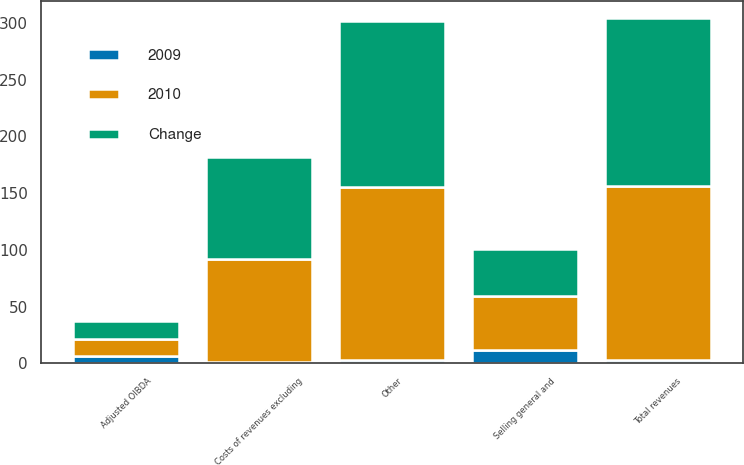Convert chart to OTSL. <chart><loc_0><loc_0><loc_500><loc_500><stacked_bar_chart><ecel><fcel>Other<fcel>Total revenues<fcel>Costs of revenues excluding<fcel>Selling general and<fcel>Adjusted OIBDA<nl><fcel>2010<fcel>152<fcel>153<fcel>91<fcel>47<fcel>15<nl><fcel>Change<fcel>147<fcel>148<fcel>90<fcel>42<fcel>16<nl><fcel>2009<fcel>3<fcel>3<fcel>1<fcel>12<fcel>6<nl></chart> 